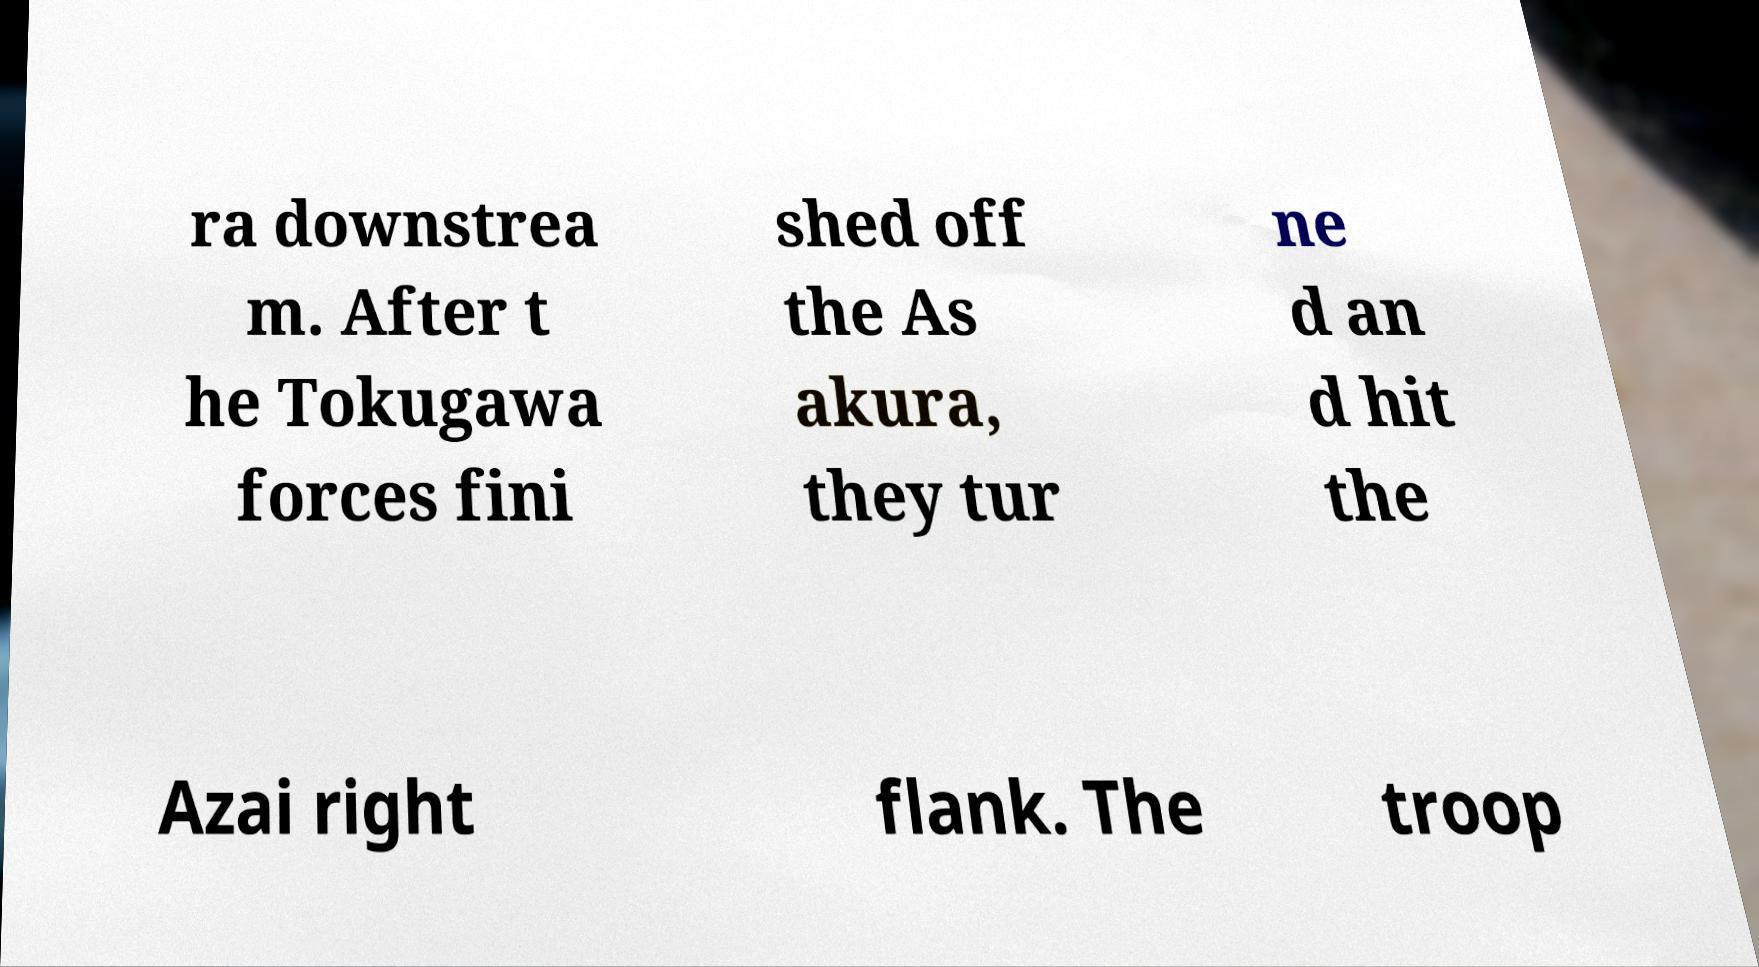I need the written content from this picture converted into text. Can you do that? ra downstrea m. After t he Tokugawa forces fini shed off the As akura, they tur ne d an d hit the Azai right flank. The troop 